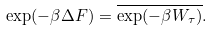<formula> <loc_0><loc_0><loc_500><loc_500>\exp ( - \beta \Delta F ) = \overline { \exp ( - \beta W _ { \tau } ) } .</formula> 